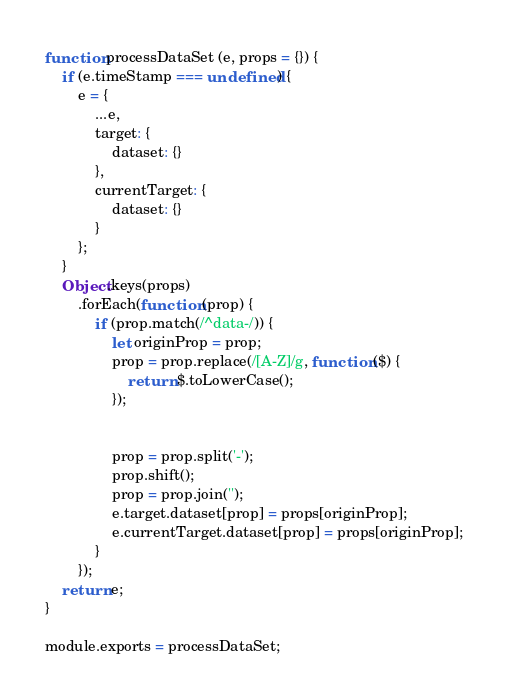<code> <loc_0><loc_0><loc_500><loc_500><_JavaScript_>function processDataSet (e, props = {}) {
    if (e.timeStamp === undefined) {
        e = {
            ...e,
            target: {
                dataset: {}
            },
            currentTarget: {
                dataset: {}
            }
        };
    }
    Object.keys(props)
        .forEach(function (prop) {
            if (prop.match(/^data-/)) {
                let originProp = prop;
                prop = prop.replace(/[A-Z]/g, function ($) {
                    return $.toLowerCase();
                });


                prop = prop.split('-');
                prop.shift();
                prop = prop.join('');
                e.target.dataset[prop] = props[originProp];
                e.currentTarget.dataset[prop] = props[originProp];
            }
        });
    return e;
}

module.exports = processDataSet;</code> 